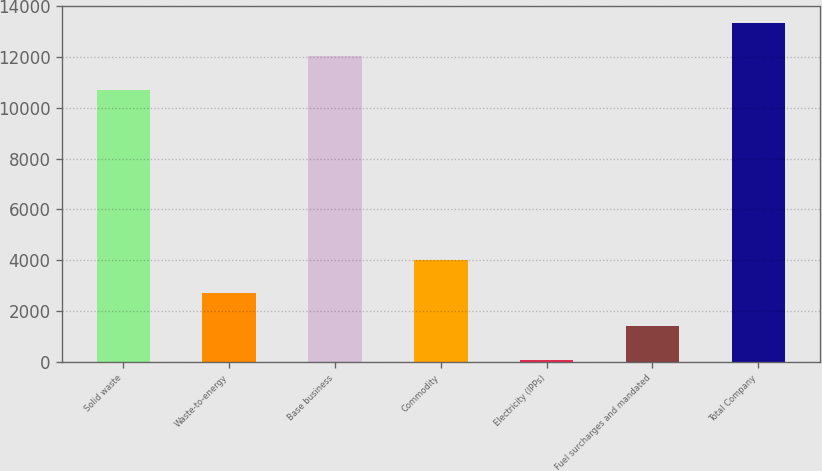<chart> <loc_0><loc_0><loc_500><loc_500><bar_chart><fcel>Solid waste<fcel>Waste-to-energy<fcel>Base business<fcel>Commodity<fcel>Electricity (IPPs)<fcel>Fuel surcharges and mandated<fcel>Total Company<nl><fcel>10715<fcel>2695.2<fcel>12025.6<fcel>4005.8<fcel>74<fcel>1384.6<fcel>13336.2<nl></chart> 